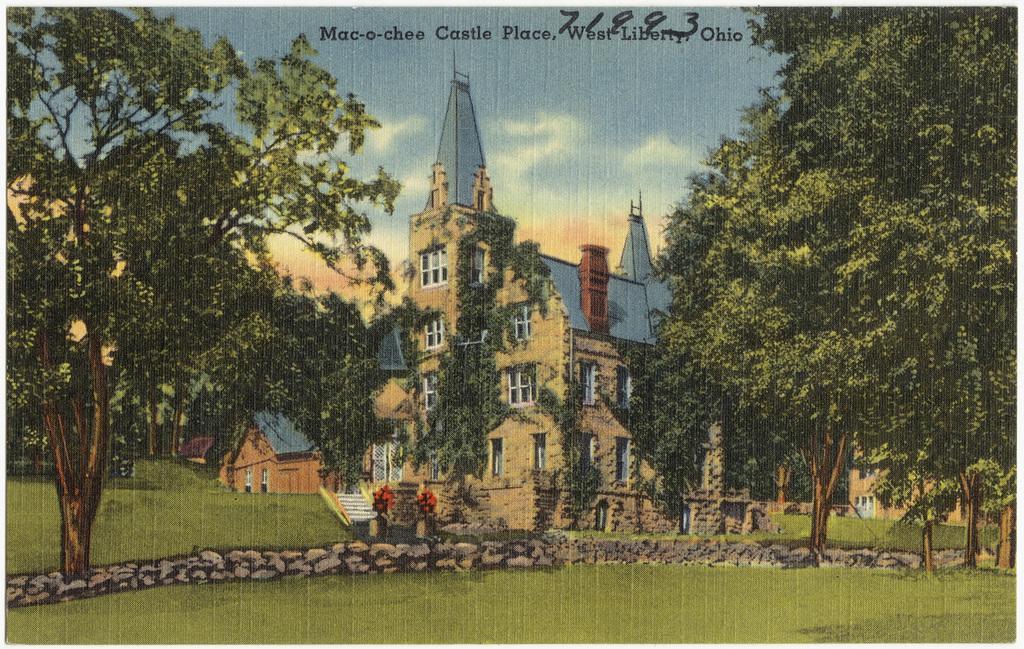Please provide a concise description of this image. In this image, we can see a poster with some images and text. 